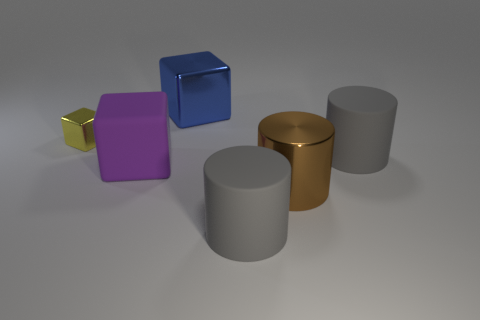Is there any other thing that is the same size as the yellow object?
Make the answer very short. No. Are there an equal number of metallic cylinders that are on the left side of the tiny thing and tiny yellow shiny things in front of the large brown object?
Offer a terse response. Yes. There is a object on the left side of the purple thing; is its shape the same as the large blue metal object?
Your response must be concise. Yes. Is the large blue shiny object the same shape as the brown shiny thing?
Make the answer very short. No. What number of matte objects are brown blocks or purple cubes?
Your response must be concise. 1. Does the rubber block have the same size as the yellow thing?
Your response must be concise. No. What number of things are gray rubber cylinders or gray cylinders right of the brown object?
Your answer should be very brief. 2. What is the material of the purple cube that is the same size as the blue shiny thing?
Your answer should be very brief. Rubber. The big object that is behind the large rubber cube and on the left side of the shiny cylinder is made of what material?
Ensure brevity in your answer.  Metal. There is a big thing on the left side of the big blue shiny thing; is there a large brown metallic object to the right of it?
Offer a terse response. Yes. 